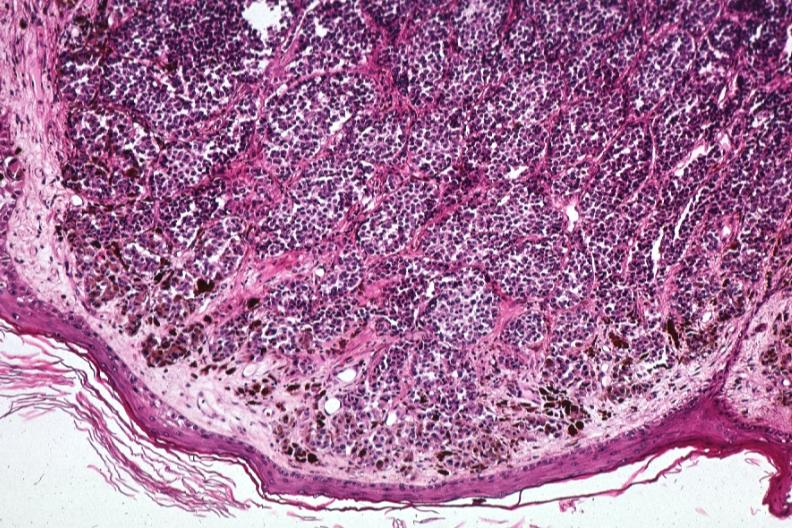s unopened larynx seen from above edema present?
Answer the question using a single word or phrase. No 